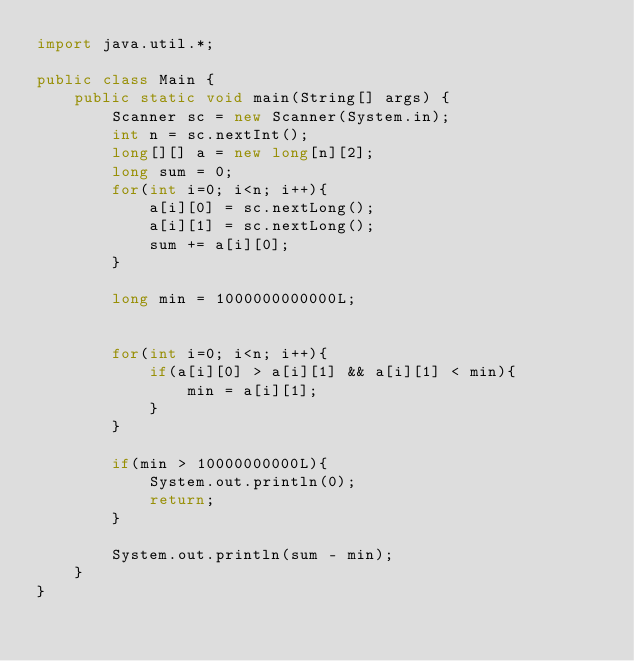Convert code to text. <code><loc_0><loc_0><loc_500><loc_500><_Java_>import java.util.*;

public class Main {
    public static void main(String[] args) {
        Scanner sc = new Scanner(System.in);
        int n = sc.nextInt();
        long[][] a = new long[n][2];
        long sum = 0;
        for(int i=0; i<n; i++){
            a[i][0] = sc.nextLong();
            a[i][1] = sc.nextLong();
            sum += a[i][0];
        }

        long min = 1000000000000L;
        

        for(int i=0; i<n; i++){
            if(a[i][0] > a[i][1] && a[i][1] < min){
                min = a[i][1];
            }
        }

        if(min > 10000000000L){
            System.out.println(0);
            return;
        }

        System.out.println(sum - min);
    }
}</code> 